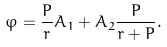<formula> <loc_0><loc_0><loc_500><loc_500>\varphi = \frac { P } { r } A _ { 1 } + A _ { 2 } \frac { P } { r + P } .</formula> 